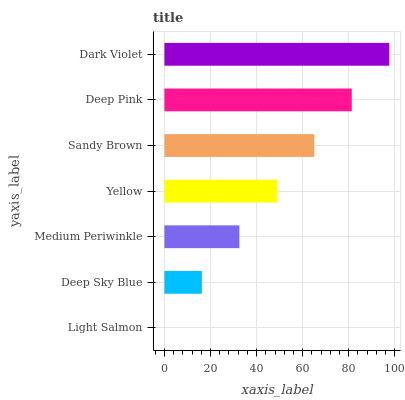Is Light Salmon the minimum?
Answer yes or no. Yes. Is Dark Violet the maximum?
Answer yes or no. Yes. Is Deep Sky Blue the minimum?
Answer yes or no. No. Is Deep Sky Blue the maximum?
Answer yes or no. No. Is Deep Sky Blue greater than Light Salmon?
Answer yes or no. Yes. Is Light Salmon less than Deep Sky Blue?
Answer yes or no. Yes. Is Light Salmon greater than Deep Sky Blue?
Answer yes or no. No. Is Deep Sky Blue less than Light Salmon?
Answer yes or no. No. Is Yellow the high median?
Answer yes or no. Yes. Is Yellow the low median?
Answer yes or no. Yes. Is Light Salmon the high median?
Answer yes or no. No. Is Medium Periwinkle the low median?
Answer yes or no. No. 